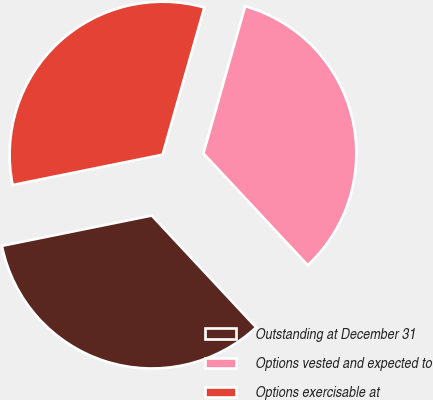Convert chart to OTSL. <chart><loc_0><loc_0><loc_500><loc_500><pie_chart><fcel>Outstanding at December 31<fcel>Options vested and expected to<fcel>Options exercisable at<nl><fcel>33.77%<fcel>33.65%<fcel>32.58%<nl></chart> 